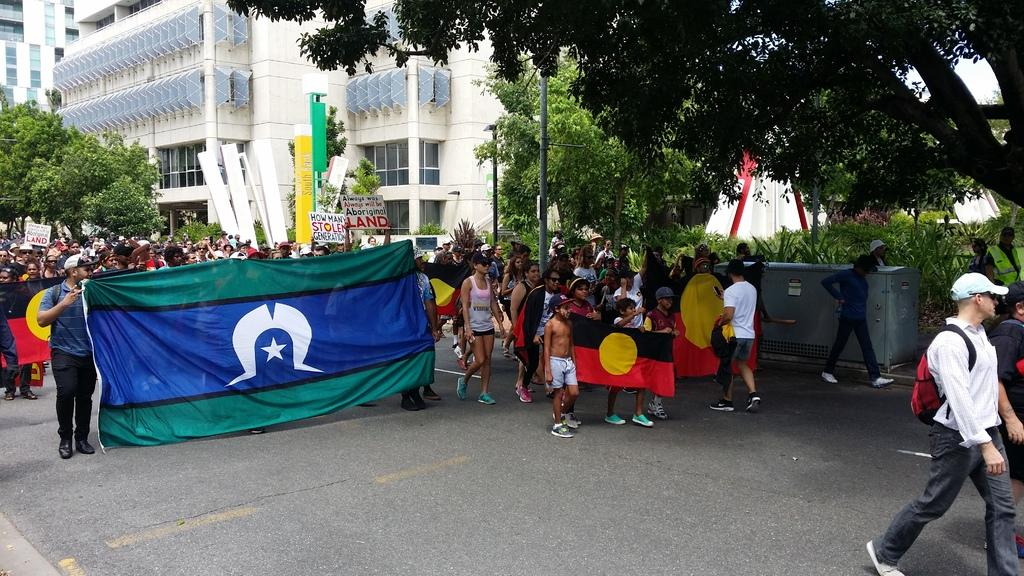What are the people in the image doing? The people in the image are walking on the ground. What are the people holding while walking? The people are holding a banner. What type of natural elements can be seen in the image? There are trees in the image. What type of man-made structures are present in the image? There are buildings in the image. What other objects can be seen in the image? There is a pole, a box, and boards in the image. What time of day is depicted in the image? The provided facts do not mention the time of day, so it cannot be determined from the image. What type of art can be seen on the people's heads in the image? There is no art or any objects on the people's heads in the image. 